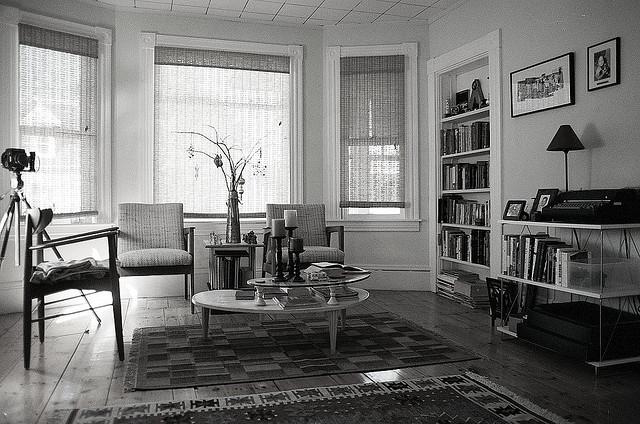How many potted plants do you see?
Quick response, please. 0. What color are the stems in the vases?
Quick response, please. Green. How many lamps are there?
Concise answer only. 1. How many windows are there?
Keep it brief. 3. What type of shelves are on the right side of the room?
Be succinct. Bookshelves. What type of seating is in this room?
Quick response, please. Chairs. 